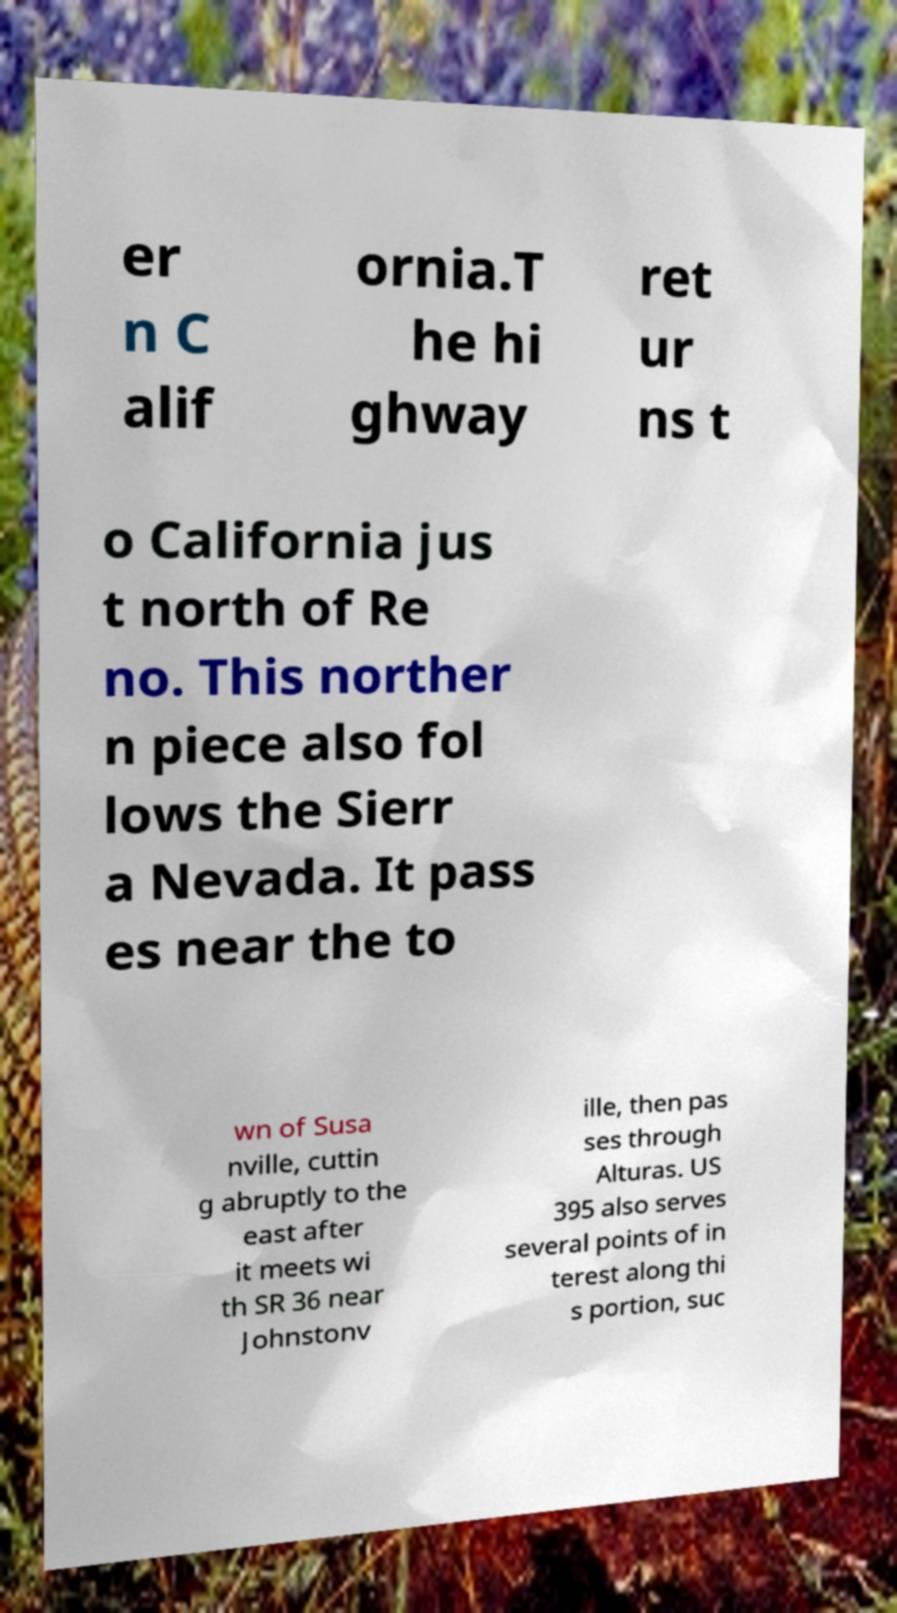Can you accurately transcribe the text from the provided image for me? er n C alif ornia.T he hi ghway ret ur ns t o California jus t north of Re no. This norther n piece also fol lows the Sierr a Nevada. It pass es near the to wn of Susa nville, cuttin g abruptly to the east after it meets wi th SR 36 near Johnstonv ille, then pas ses through Alturas. US 395 also serves several points of in terest along thi s portion, suc 